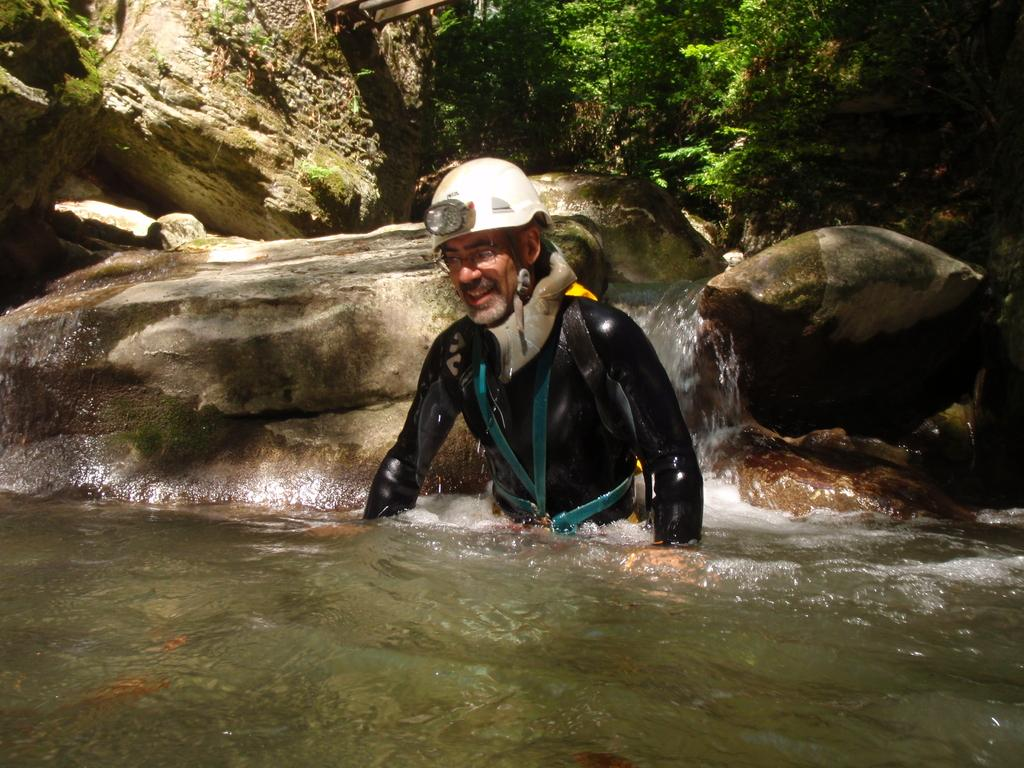What is the main subject of the image? There is a person in the image. What is the person wearing? The person is wearing a helmet. Where is the person located in the image? The person is in the water. What can be seen in the background of the image? There are stones, a waterfall, and plants in the background of the image. What type of soda can be seen floating in the water in the image? There is no soda present in the image; the person is in the water, but no beverages are visible. What color is the button on the person's helmet in the image? The person in the image is wearing a helmet, but there is no mention of a button on the helmet, so we cannot determine its color. 